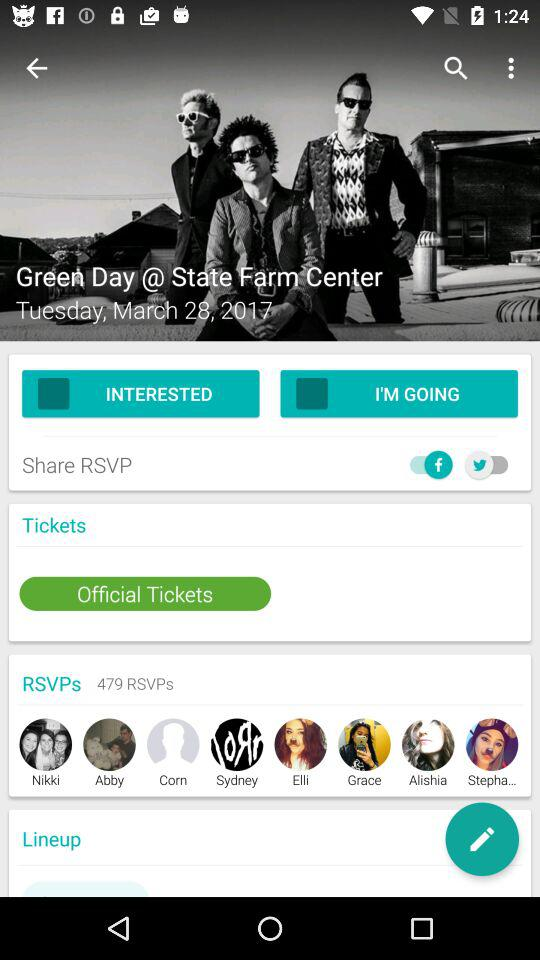How many RSVPs are there?
Answer the question using a single word or phrase. 479 